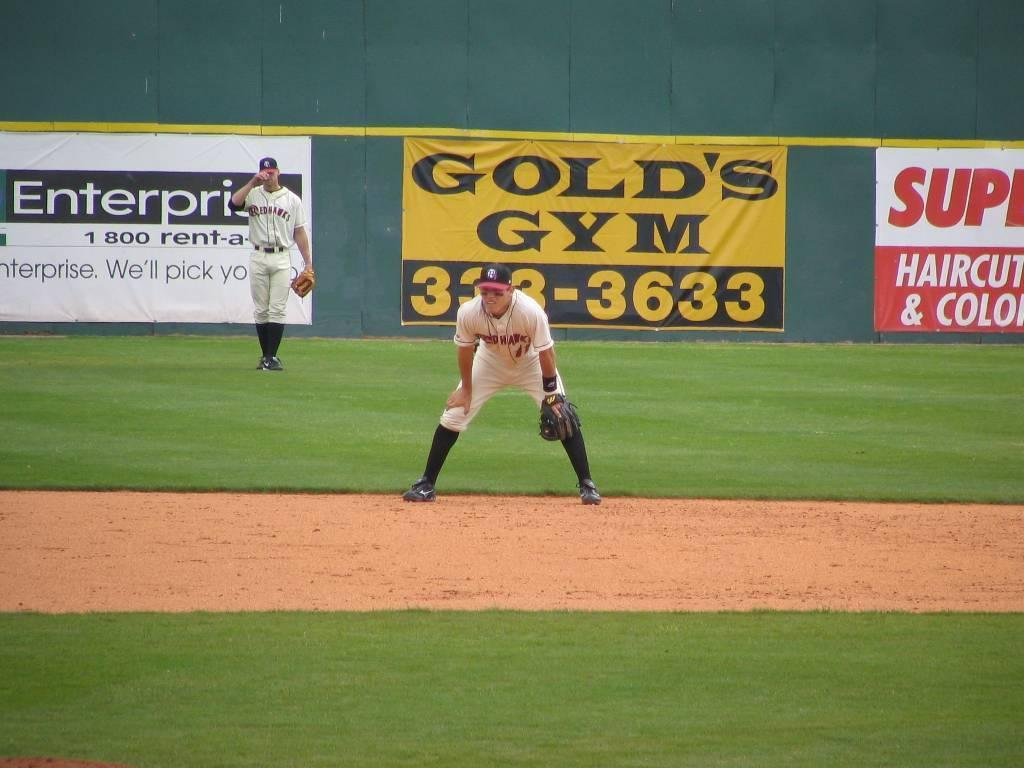<image>
Share a concise interpretation of the image provided. Two baseball players from the Redhawks team are on a field in front of a Gold's Gym sign. 